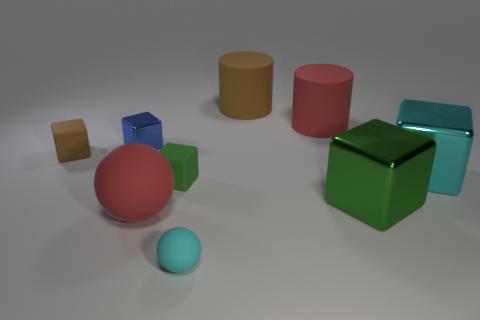Subtract all brown blocks. How many blocks are left? 4 Subtract all brown matte cubes. How many cubes are left? 4 Subtract all red blocks. Subtract all gray cylinders. How many blocks are left? 5 Add 1 cyan matte spheres. How many objects exist? 10 Subtract all cylinders. How many objects are left? 7 Add 6 big red things. How many big red things are left? 8 Add 8 big cyan metal blocks. How many big cyan metal blocks exist? 9 Subtract 0 purple spheres. How many objects are left? 9 Subtract all tiny matte blocks. Subtract all blue shiny cubes. How many objects are left? 6 